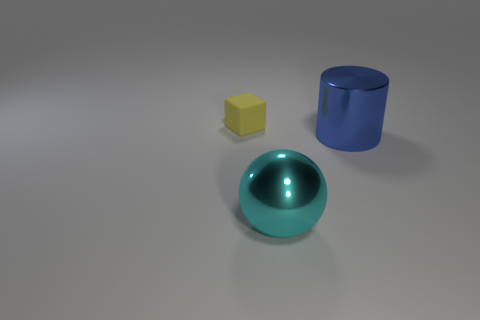Can you describe the lighting in this scene? The lighting in this scene is soft and diffused, with a brighter area suggesting a light source above and slightly to the right. Shadows are gentle and extend towards the left, indicating that the light comes from the upper right direction. The overall ambiance is neutral, suggesting an indoor setting without direct sunlight. 